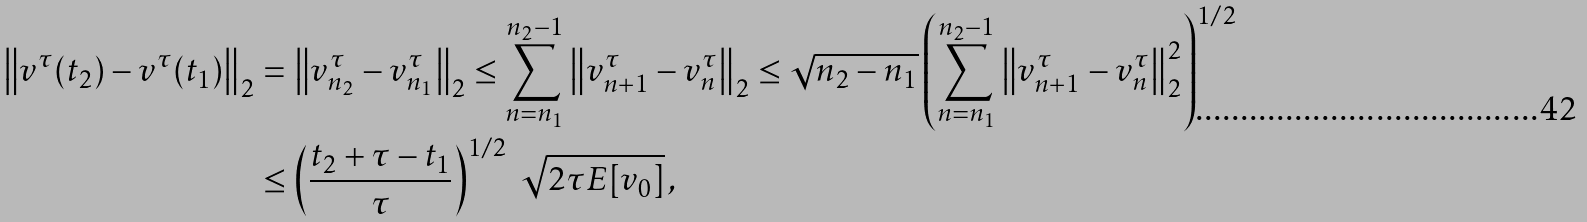Convert formula to latex. <formula><loc_0><loc_0><loc_500><loc_500>\left \| v ^ { \tau } ( t _ { 2 } ) - v ^ { \tau } ( t _ { 1 } ) \right \| _ { 2 } & = \left \| v _ { n _ { 2 } } ^ { \tau } - v _ { n _ { 1 } } ^ { \tau } \right \| _ { 2 } \leq \sum _ { n = n _ { 1 } } ^ { n _ { 2 } - 1 } \left \| v _ { n + 1 } ^ { \tau } - v _ { n } ^ { \tau } \right \| _ { 2 } \leq \sqrt { n _ { 2 } - n _ { 1 } } \left ( \sum _ { n = n _ { 1 } } ^ { n _ { 2 } - 1 } \left \| v _ { n + 1 } ^ { \tau } - v _ { n } ^ { \tau } \right \| _ { 2 } ^ { 2 } \right ) ^ { 1 / 2 } \\ & \leq \left ( \frac { t _ { 2 } + \tau - t _ { 1 } } { \tau } \right ) ^ { 1 / 2 } \ \sqrt { 2 \tau E [ v _ { 0 } ] } \, ,</formula> 